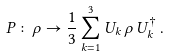<formula> <loc_0><loc_0><loc_500><loc_500>P \colon \rho \rightarrow \frac { 1 } { 3 } \sum _ { k = 1 } ^ { 3 } U _ { k } \, \rho \, U _ { k } ^ { \dagger } \, .</formula> 